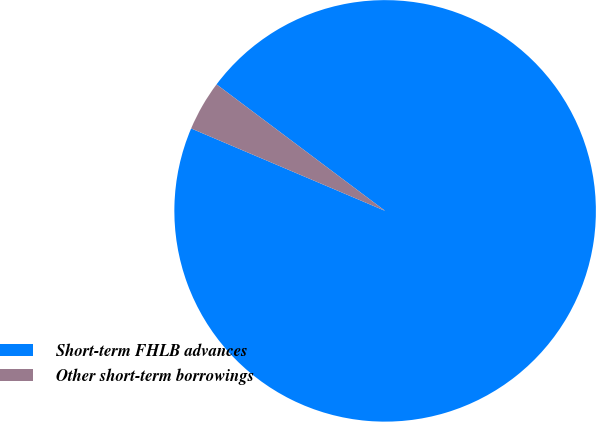<chart> <loc_0><loc_0><loc_500><loc_500><pie_chart><fcel>Short-term FHLB advances<fcel>Other short-term borrowings<nl><fcel>96.15%<fcel>3.85%<nl></chart> 